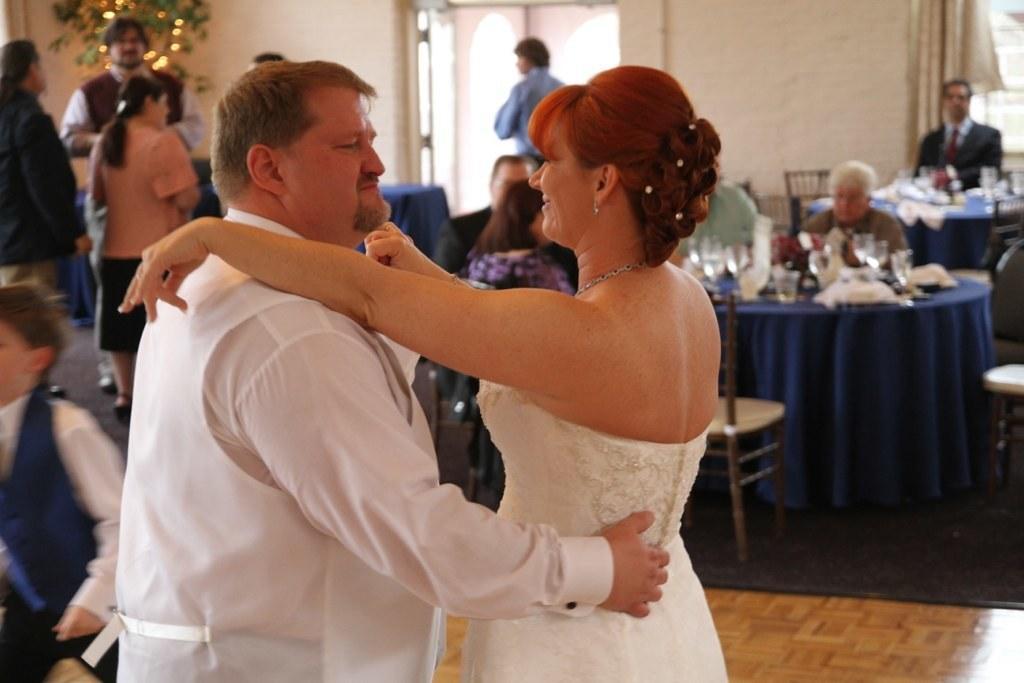How would you summarize this image in a sentence or two? The persons wearing white dress is holding each other and there are group of people beside them. 